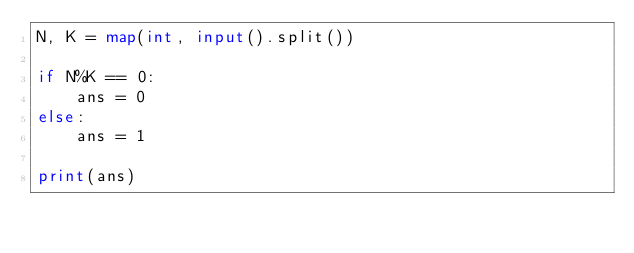<code> <loc_0><loc_0><loc_500><loc_500><_Python_>N, K = map(int, input().split())

if N%K == 0:
    ans = 0
else:
    ans = 1

print(ans)</code> 